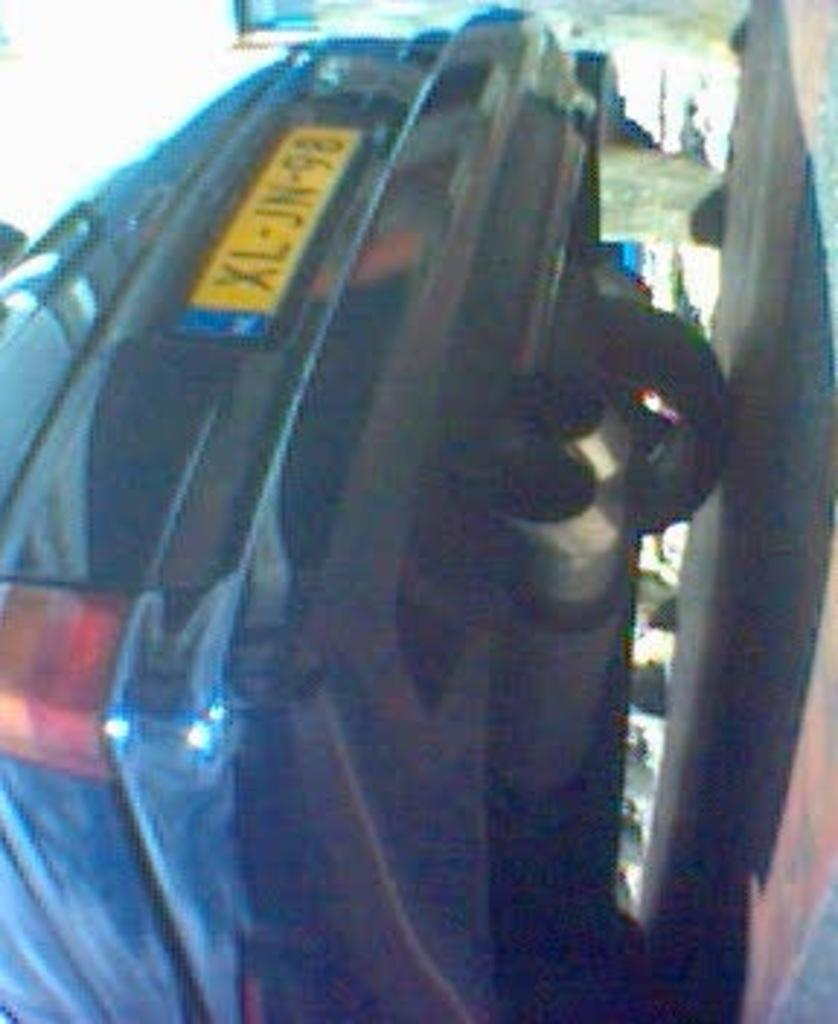What is the main subject of the image? There is a car in the image. What can be seen on the right side of the image? There is a road on the right side of the image. How would you describe the background of the image? The background of the image is blurred. Can you see an apple hanging from a tree in the background of the image? There is no apple or tree present in the image; the background is blurred. 